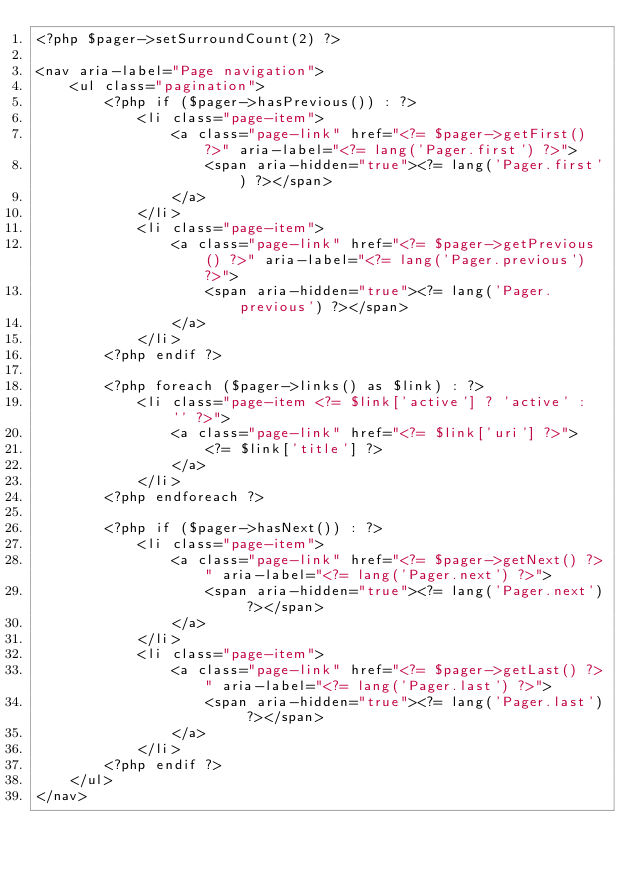<code> <loc_0><loc_0><loc_500><loc_500><_PHP_><?php $pager->setSurroundCount(2) ?>

<nav aria-label="Page navigation">
    <ul class="pagination">
        <?php if ($pager->hasPrevious()) : ?>
            <li class="page-item">
                <a class="page-link" href="<?= $pager->getFirst() ?>" aria-label="<?= lang('Pager.first') ?>">
                    <span aria-hidden="true"><?= lang('Pager.first') ?></span>
                </a>
            </li>
            <li class="page-item">
                <a class="page-link" href="<?= $pager->getPrevious() ?>" aria-label="<?= lang('Pager.previous') ?>">
                    <span aria-hidden="true"><?= lang('Pager.previous') ?></span>
                </a>
            </li>
        <?php endif ?>

        <?php foreach ($pager->links() as $link) : ?>
            <li class="page-item <?= $link['active'] ? 'active' : '' ?>">
                <a class="page-link" href="<?= $link['uri'] ?>">
                    <?= $link['title'] ?>
                </a>
            </li>
        <?php endforeach ?>

        <?php if ($pager->hasNext()) : ?>
            <li class="page-item">
                <a class="page-link" href="<?= $pager->getNext() ?>" aria-label="<?= lang('Pager.next') ?>">
                    <span aria-hidden="true"><?= lang('Pager.next') ?></span>
                </a>
            </li>
            <li class="page-item">
                <a class="page-link" href="<?= $pager->getLast() ?>" aria-label="<?= lang('Pager.last') ?>">
                    <span aria-hidden="true"><?= lang('Pager.last') ?></span>
                </a>
            </li>
        <?php endif ?>
    </ul>
</nav></code> 